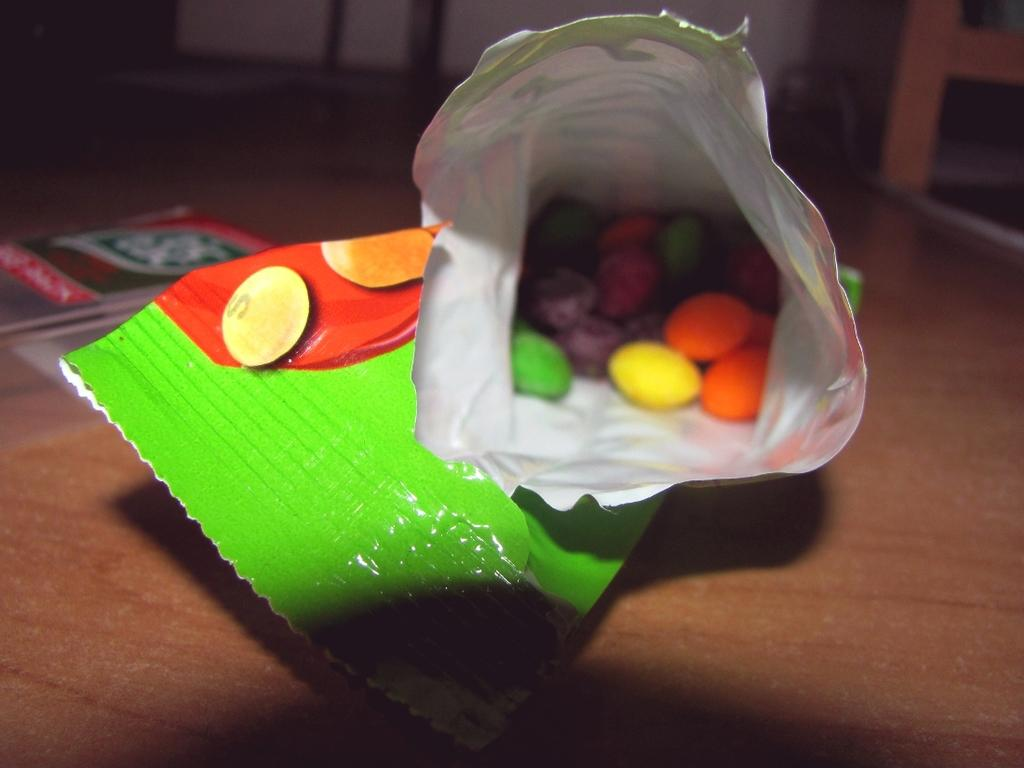What is covered in the image? There are food items in a cover. What else can be seen on the table in the image? There are books on a table. What type of fan is visible in the image? There is no fan present in the image. Is there a camping site visible in the image? There is no camping site present in the image. 